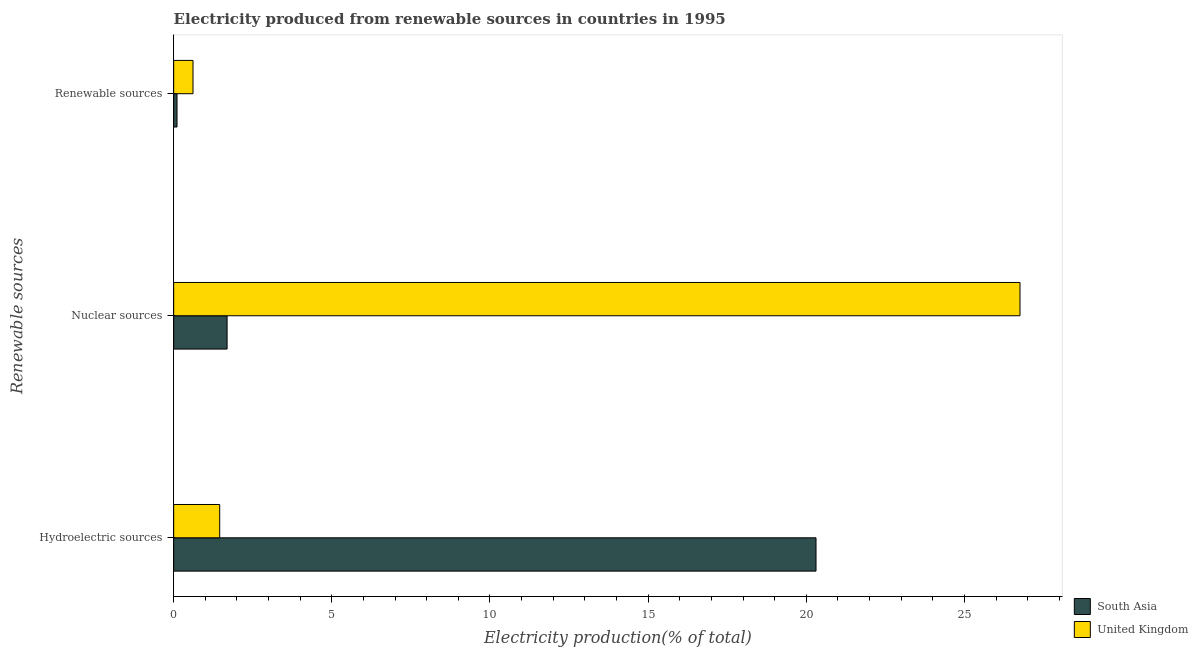How many groups of bars are there?
Offer a very short reply. 3. Are the number of bars on each tick of the Y-axis equal?
Keep it short and to the point. Yes. How many bars are there on the 3rd tick from the top?
Offer a very short reply. 2. How many bars are there on the 3rd tick from the bottom?
Ensure brevity in your answer.  2. What is the label of the 3rd group of bars from the top?
Offer a terse response. Hydroelectric sources. What is the percentage of electricity produced by hydroelectric sources in South Asia?
Offer a very short reply. 20.31. Across all countries, what is the maximum percentage of electricity produced by renewable sources?
Your answer should be very brief. 0.61. Across all countries, what is the minimum percentage of electricity produced by nuclear sources?
Offer a very short reply. 1.69. In which country was the percentage of electricity produced by hydroelectric sources maximum?
Provide a succinct answer. South Asia. In which country was the percentage of electricity produced by hydroelectric sources minimum?
Make the answer very short. United Kingdom. What is the total percentage of electricity produced by nuclear sources in the graph?
Ensure brevity in your answer.  28.45. What is the difference between the percentage of electricity produced by renewable sources in United Kingdom and that in South Asia?
Your response must be concise. 0.51. What is the difference between the percentage of electricity produced by hydroelectric sources in United Kingdom and the percentage of electricity produced by nuclear sources in South Asia?
Give a very brief answer. -0.23. What is the average percentage of electricity produced by nuclear sources per country?
Provide a succinct answer. 14.22. What is the difference between the percentage of electricity produced by renewable sources and percentage of electricity produced by nuclear sources in United Kingdom?
Make the answer very short. -26.15. In how many countries, is the percentage of electricity produced by nuclear sources greater than 13 %?
Offer a terse response. 1. What is the ratio of the percentage of electricity produced by renewable sources in South Asia to that in United Kingdom?
Your answer should be compact. 0.17. Is the difference between the percentage of electricity produced by nuclear sources in United Kingdom and South Asia greater than the difference between the percentage of electricity produced by renewable sources in United Kingdom and South Asia?
Your answer should be very brief. Yes. What is the difference between the highest and the second highest percentage of electricity produced by renewable sources?
Provide a succinct answer. 0.51. What is the difference between the highest and the lowest percentage of electricity produced by renewable sources?
Keep it short and to the point. 0.51. What does the 2nd bar from the bottom in Nuclear sources represents?
Your answer should be compact. United Kingdom. Is it the case that in every country, the sum of the percentage of electricity produced by hydroelectric sources and percentage of electricity produced by nuclear sources is greater than the percentage of electricity produced by renewable sources?
Keep it short and to the point. Yes. Are all the bars in the graph horizontal?
Provide a short and direct response. Yes. How are the legend labels stacked?
Keep it short and to the point. Vertical. What is the title of the graph?
Give a very brief answer. Electricity produced from renewable sources in countries in 1995. What is the label or title of the Y-axis?
Make the answer very short. Renewable sources. What is the Electricity production(% of total) of South Asia in Hydroelectric sources?
Keep it short and to the point. 20.31. What is the Electricity production(% of total) in United Kingdom in Hydroelectric sources?
Offer a very short reply. 1.46. What is the Electricity production(% of total) in South Asia in Nuclear sources?
Provide a short and direct response. 1.69. What is the Electricity production(% of total) of United Kingdom in Nuclear sources?
Offer a terse response. 26.76. What is the Electricity production(% of total) in South Asia in Renewable sources?
Your response must be concise. 0.11. What is the Electricity production(% of total) of United Kingdom in Renewable sources?
Your answer should be compact. 0.61. Across all Renewable sources, what is the maximum Electricity production(% of total) in South Asia?
Make the answer very short. 20.31. Across all Renewable sources, what is the maximum Electricity production(% of total) of United Kingdom?
Offer a terse response. 26.76. Across all Renewable sources, what is the minimum Electricity production(% of total) in South Asia?
Your answer should be compact. 0.11. Across all Renewable sources, what is the minimum Electricity production(% of total) of United Kingdom?
Your answer should be compact. 0.61. What is the total Electricity production(% of total) of South Asia in the graph?
Offer a terse response. 22.1. What is the total Electricity production(% of total) of United Kingdom in the graph?
Keep it short and to the point. 28.82. What is the difference between the Electricity production(% of total) in South Asia in Hydroelectric sources and that in Nuclear sources?
Give a very brief answer. 18.62. What is the difference between the Electricity production(% of total) in United Kingdom in Hydroelectric sources and that in Nuclear sources?
Offer a terse response. -25.3. What is the difference between the Electricity production(% of total) in South Asia in Hydroelectric sources and that in Renewable sources?
Provide a short and direct response. 20.2. What is the difference between the Electricity production(% of total) of United Kingdom in Hydroelectric sources and that in Renewable sources?
Your answer should be very brief. 0.84. What is the difference between the Electricity production(% of total) in South Asia in Nuclear sources and that in Renewable sources?
Keep it short and to the point. 1.58. What is the difference between the Electricity production(% of total) of United Kingdom in Nuclear sources and that in Renewable sources?
Provide a short and direct response. 26.15. What is the difference between the Electricity production(% of total) in South Asia in Hydroelectric sources and the Electricity production(% of total) in United Kingdom in Nuclear sources?
Make the answer very short. -6.45. What is the difference between the Electricity production(% of total) of South Asia in Hydroelectric sources and the Electricity production(% of total) of United Kingdom in Renewable sources?
Provide a succinct answer. 19.7. What is the difference between the Electricity production(% of total) in South Asia in Nuclear sources and the Electricity production(% of total) in United Kingdom in Renewable sources?
Provide a succinct answer. 1.08. What is the average Electricity production(% of total) of South Asia per Renewable sources?
Your response must be concise. 7.37. What is the average Electricity production(% of total) of United Kingdom per Renewable sources?
Offer a terse response. 9.61. What is the difference between the Electricity production(% of total) of South Asia and Electricity production(% of total) of United Kingdom in Hydroelectric sources?
Make the answer very short. 18.85. What is the difference between the Electricity production(% of total) of South Asia and Electricity production(% of total) of United Kingdom in Nuclear sources?
Your answer should be compact. -25.07. What is the difference between the Electricity production(% of total) of South Asia and Electricity production(% of total) of United Kingdom in Renewable sources?
Your answer should be very brief. -0.51. What is the ratio of the Electricity production(% of total) in South Asia in Hydroelectric sources to that in Nuclear sources?
Your answer should be very brief. 12.02. What is the ratio of the Electricity production(% of total) in United Kingdom in Hydroelectric sources to that in Nuclear sources?
Keep it short and to the point. 0.05. What is the ratio of the Electricity production(% of total) of South Asia in Hydroelectric sources to that in Renewable sources?
Keep it short and to the point. 192.05. What is the ratio of the Electricity production(% of total) of United Kingdom in Hydroelectric sources to that in Renewable sources?
Keep it short and to the point. 2.38. What is the ratio of the Electricity production(% of total) in South Asia in Nuclear sources to that in Renewable sources?
Provide a short and direct response. 15.97. What is the ratio of the Electricity production(% of total) of United Kingdom in Nuclear sources to that in Renewable sources?
Offer a terse response. 43.76. What is the difference between the highest and the second highest Electricity production(% of total) in South Asia?
Give a very brief answer. 18.62. What is the difference between the highest and the second highest Electricity production(% of total) of United Kingdom?
Provide a short and direct response. 25.3. What is the difference between the highest and the lowest Electricity production(% of total) of South Asia?
Make the answer very short. 20.2. What is the difference between the highest and the lowest Electricity production(% of total) in United Kingdom?
Your answer should be compact. 26.15. 